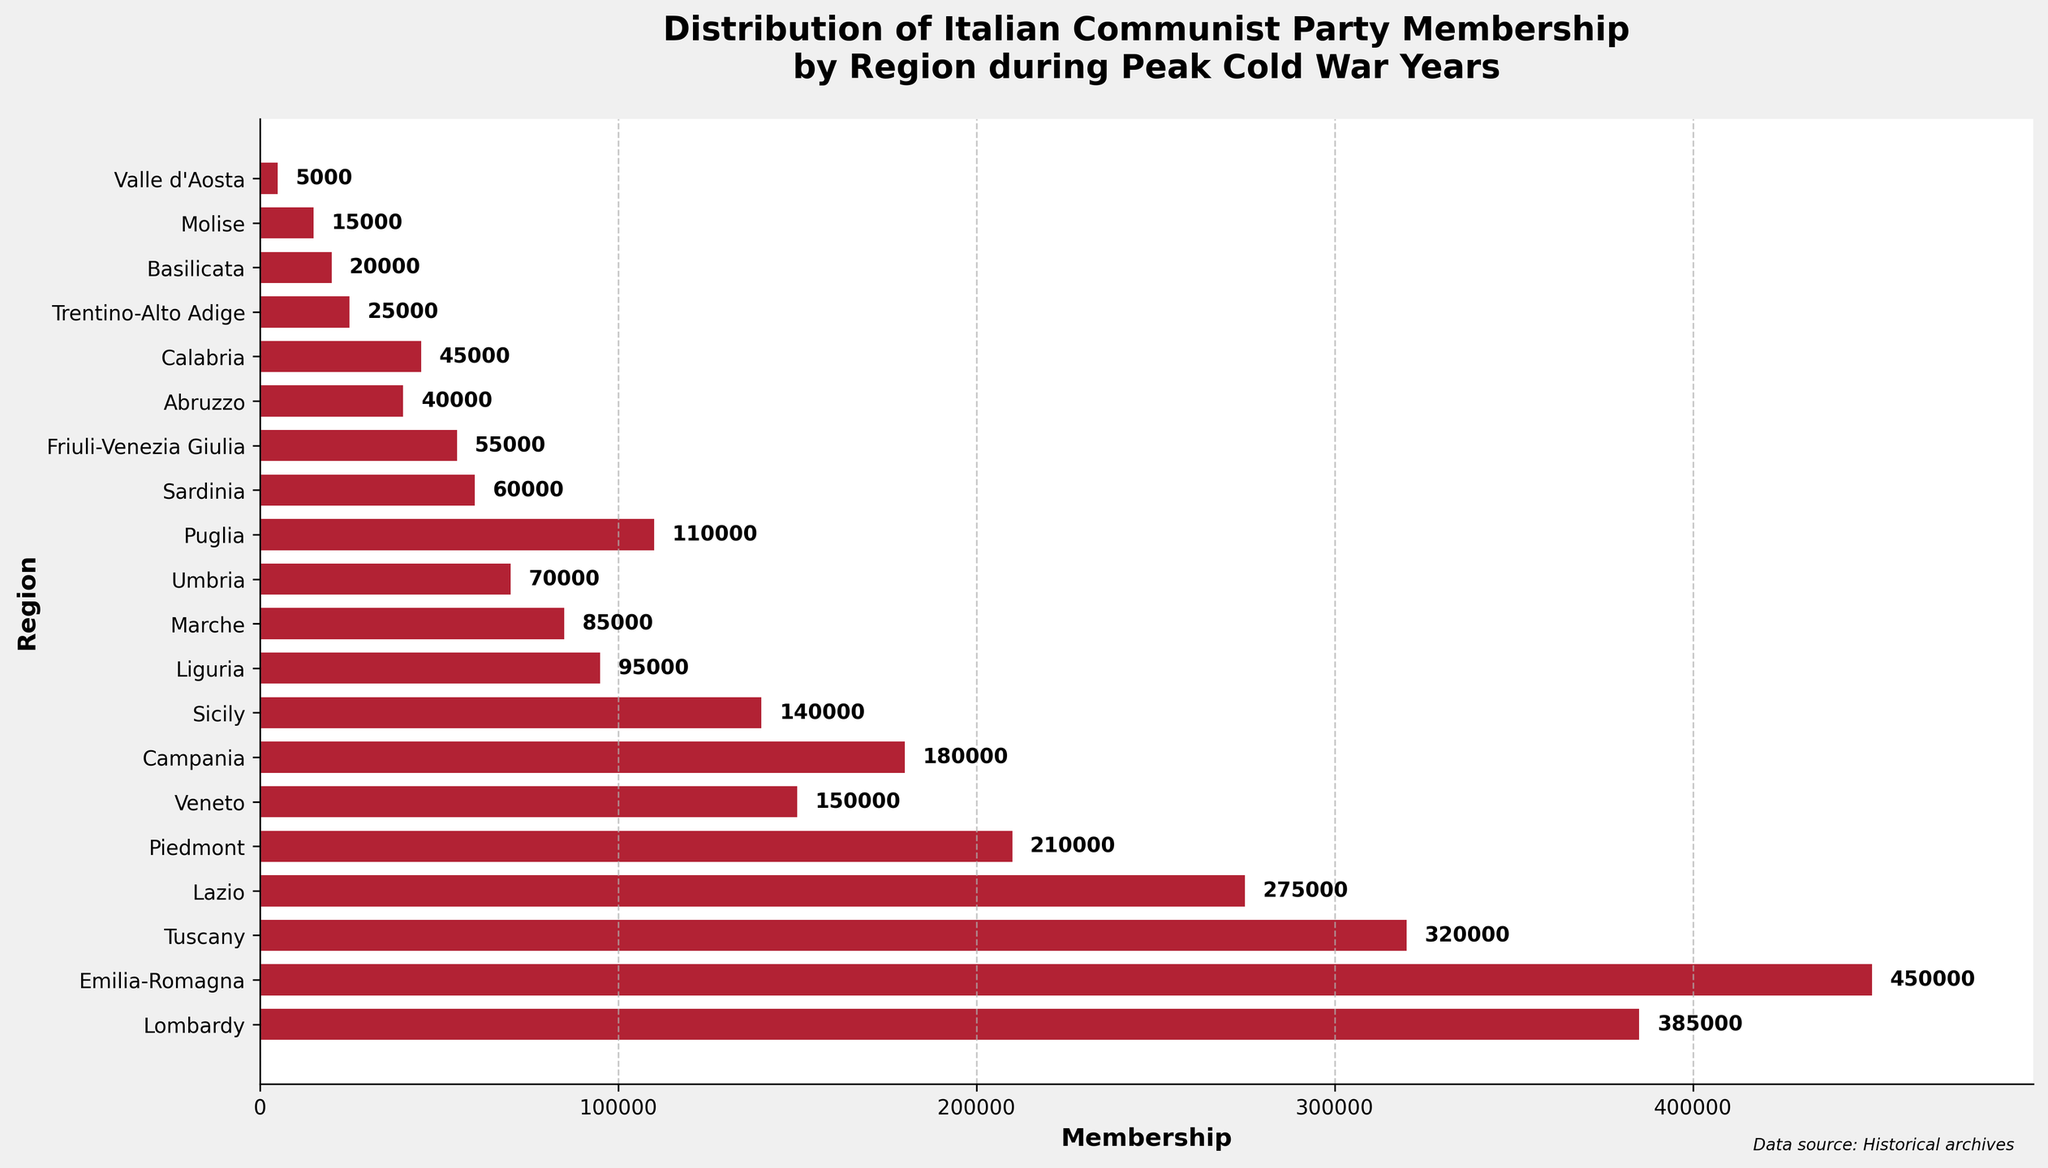What region has the highest membership in the Italian Communist Party according to the chart? The height of the bars corresponds to the membership numbers. The bar representing Emilia-Romagna is the tallest, indicating that it has the highest membership.
Answer: Emilia-Romagna Which region has the lowest membership? The region with the shortest bar represents the lowest membership. The bar for Valle d'Aosta is the shortest.
Answer: Valle d'Aosta How many regions have a membership of 150,000 or more? Count the number of bars with lengths that indicate memberships of 150,000 or more. Lombardy, Emilia-Romagna, Tuscany, Lazio, and Piedmont meet this criterion.
Answer: 5 What is the total membership for regions with less than 100,000 members? Sum the memberships of regions with each bar length indicating less than 100,000 members: Liguria (95,000), Marche (85,000), Umbria (70,000), Sardinia (60,000), Friuli-Venezia Giulia (55,000), Abruzzo (40,000), Calabria (45,000), Trentino-Alto Adige (25,000), Basilicata (20,000), Molise (15,000), Valle d'Aosta (5,000). The total is 95,000 + 85,000 + 70,000 + 60,000 + 55,000 + 40,000 + 45,000 + 25,000 + 20,000 + 15,000 + 5,000 = 515,000.
Answer: 515,000 Which regions have similar memberships just by looking at the lengths of the bars? Comparing the bars' lengths, Lazio and Tuscany have visually similar lengths, indicating comparable membership numbers.
Answer: Lazio and Tuscany What is the combined membership of Lombardy and Veneto? The membership in Lombardy is 385,000 and in Veneto is 150,000. Their combined membership is 385,000 + 150,000 = 535,000.
Answer: 535,000 Is the membership in Campania higher or lower than that in Sicily? Comparing the lengths of their bars, the bar for Campania is slightly longer than the bar for Sicily. Therefore, the membership in Campania is higher.
Answer: Higher What is the approximate range of memberships most regions fall within? Observing the lengths of the bars, most regions have memberships ranging from roughly 20,000 to 450,000.
Answer: 20,000 to 450,000 How does the membership distribution in Southern regions (e.g., Campania, Calabria, Sicily) compare to Northern regions (e.g., Lombardy, Piedmont)? The Northern regions like Lombardy and Piedmont have longer bars (indicating higher membership) compared to Southern regions like Campania, Calabria, and Sicily, which have shorter bars.
Answer: Northern regions generally have higher memberships than Southern regions What percentage of total membership does Emilia-Romagna contribute? First, find the total membership by summing all regions: 385,000 + 450,000 + 320,000 + 275,000 + 210,000 + 150,000 + 180,000 + 140,000 + 95,000 + 85,000 + 70,000 + 110,000 + 60,000 + 55,000 + 40,000 + 45,000 + 25,000 + 20,000 + 15,000 + 5,000 = 2,685,000. The membership for Emilia-Romagna is 450,000. The percentage is (450,000 / 2,685,000) * 100 ≈ 16.76%.
Answer: Approximately 16.76% 